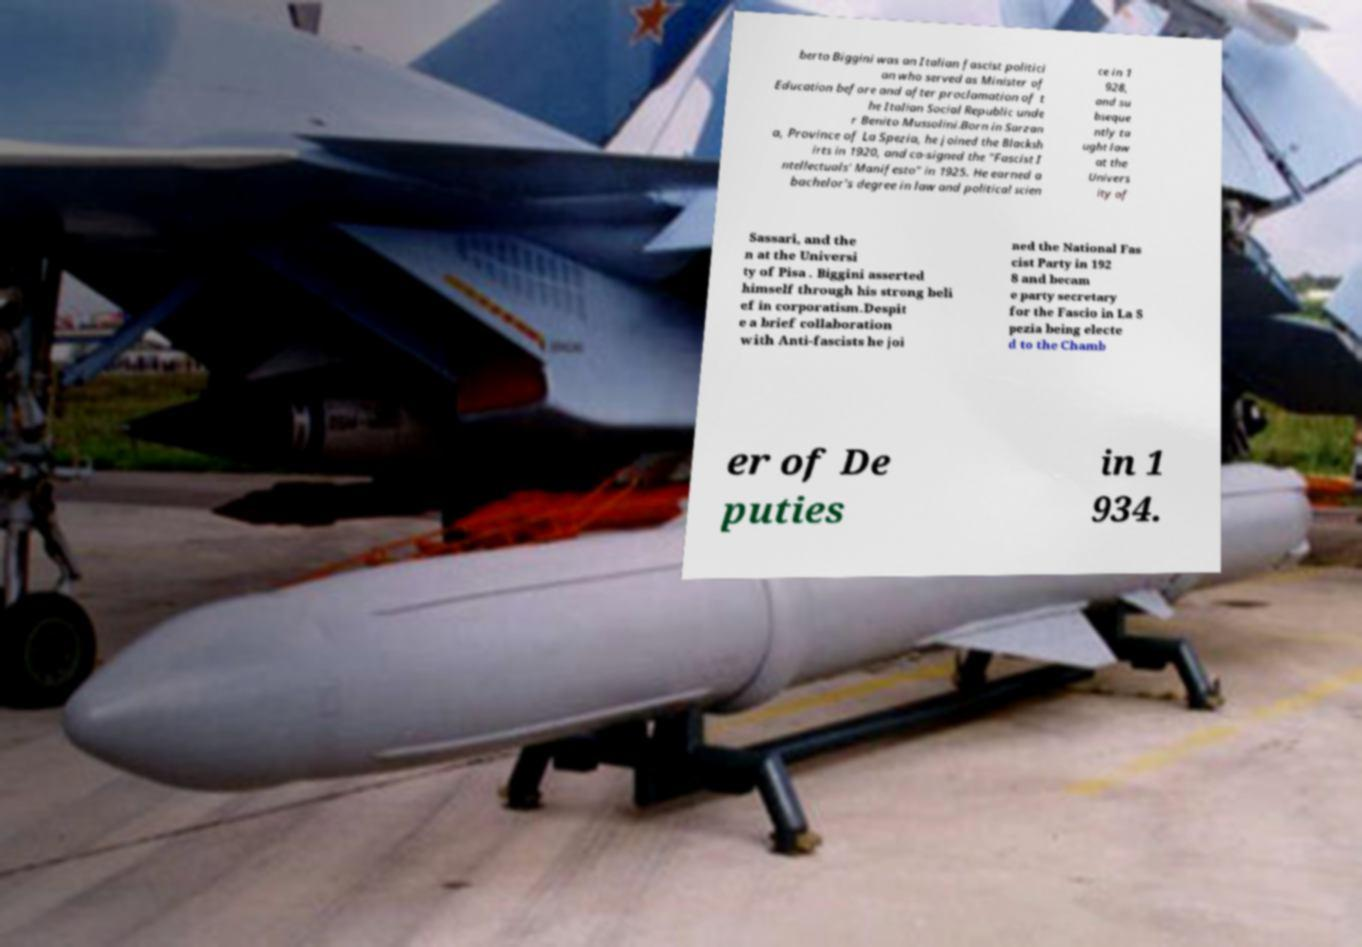Could you assist in decoding the text presented in this image and type it out clearly? berto Biggini was an Italian fascist politici an who served as Minister of Education before and after proclamation of t he Italian Social Republic unde r Benito Mussolini.Born in Sarzan a, Province of La Spezia, he joined the Blacksh irts in 1920, and co-signed the "Fascist I ntellectuals' Manifesto" in 1925. He earned a bachelor's degree in law and political scien ce in 1 928, and su bseque ntly ta ught law at the Univers ity of Sassari, and the n at the Universi ty of Pisa . Biggini asserted himself through his strong beli ef in corporatism.Despit e a brief collaboration with Anti-fascists he joi ned the National Fas cist Party in 192 8 and becam e party secretary for the Fascio in La S pezia being electe d to the Chamb er of De puties in 1 934. 